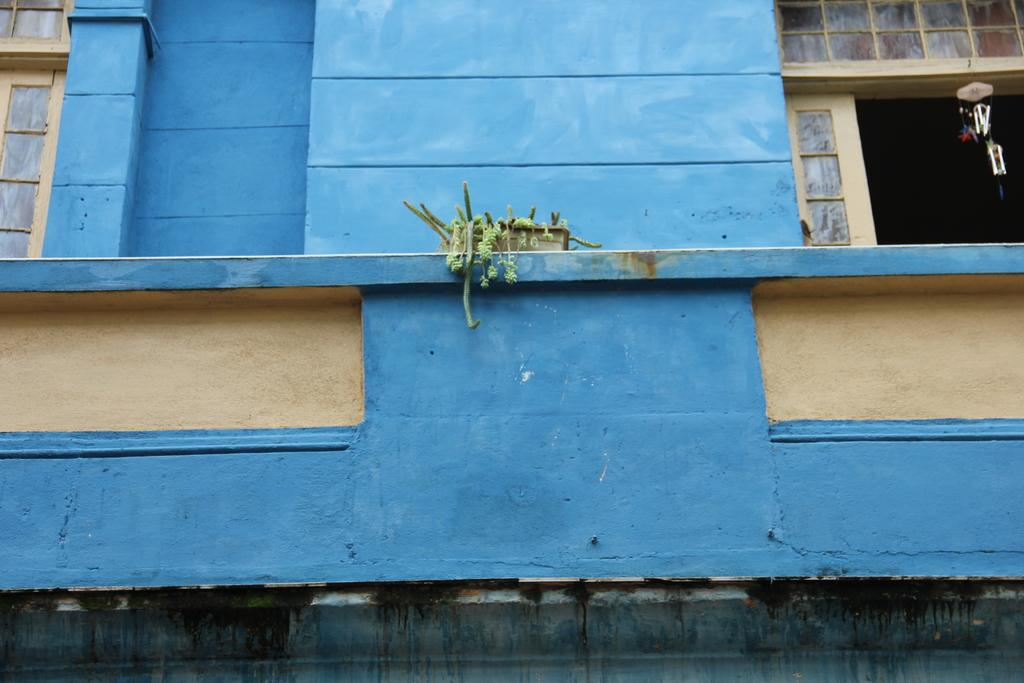What color is the wall in the image? The wall in the image is blue. What feature does the wall have? The wall has windows. What can be seen in the middle of the image? There is a plant in the middle of the image. Where is the mark on the wall in the image? There is no mark present on the wall in the image. 